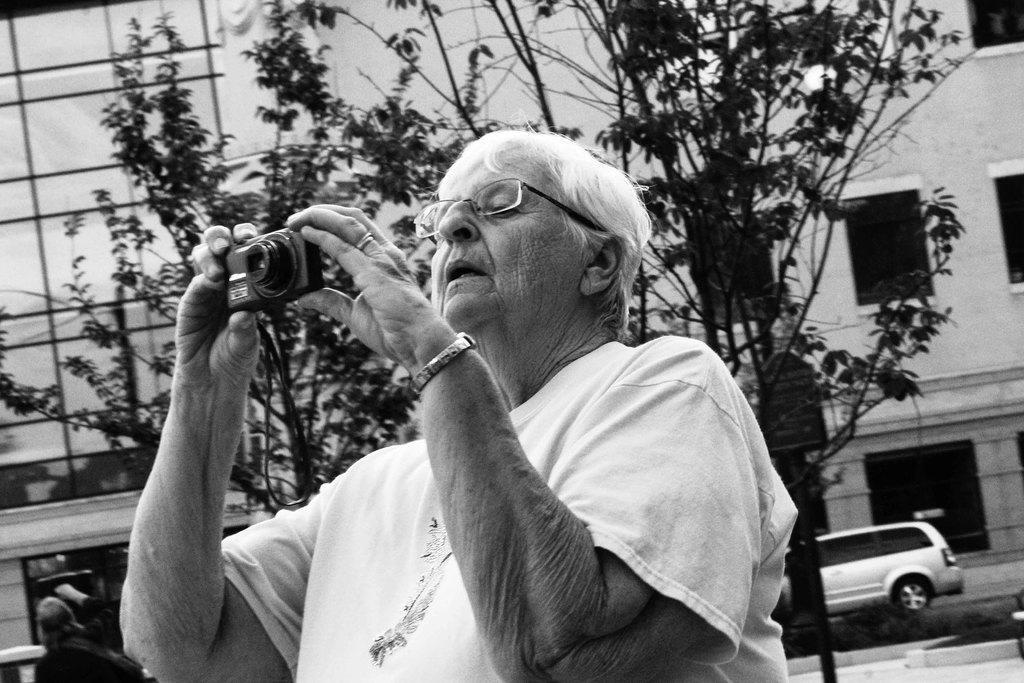In one or two sentences, can you explain what this image depicts? In this picture we can see a person holding a camera in his hands. We can see another person on the left side. There are few trees, a board on the pole, building and a vehicle in the background. 